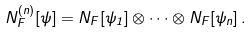<formula> <loc_0><loc_0><loc_500><loc_500>N ^ { ( n ) } _ { F } [ \psi ] = N _ { F } [ \psi _ { 1 } ] \otimes \dots \otimes N _ { F } [ \psi _ { n } ] \, .</formula> 